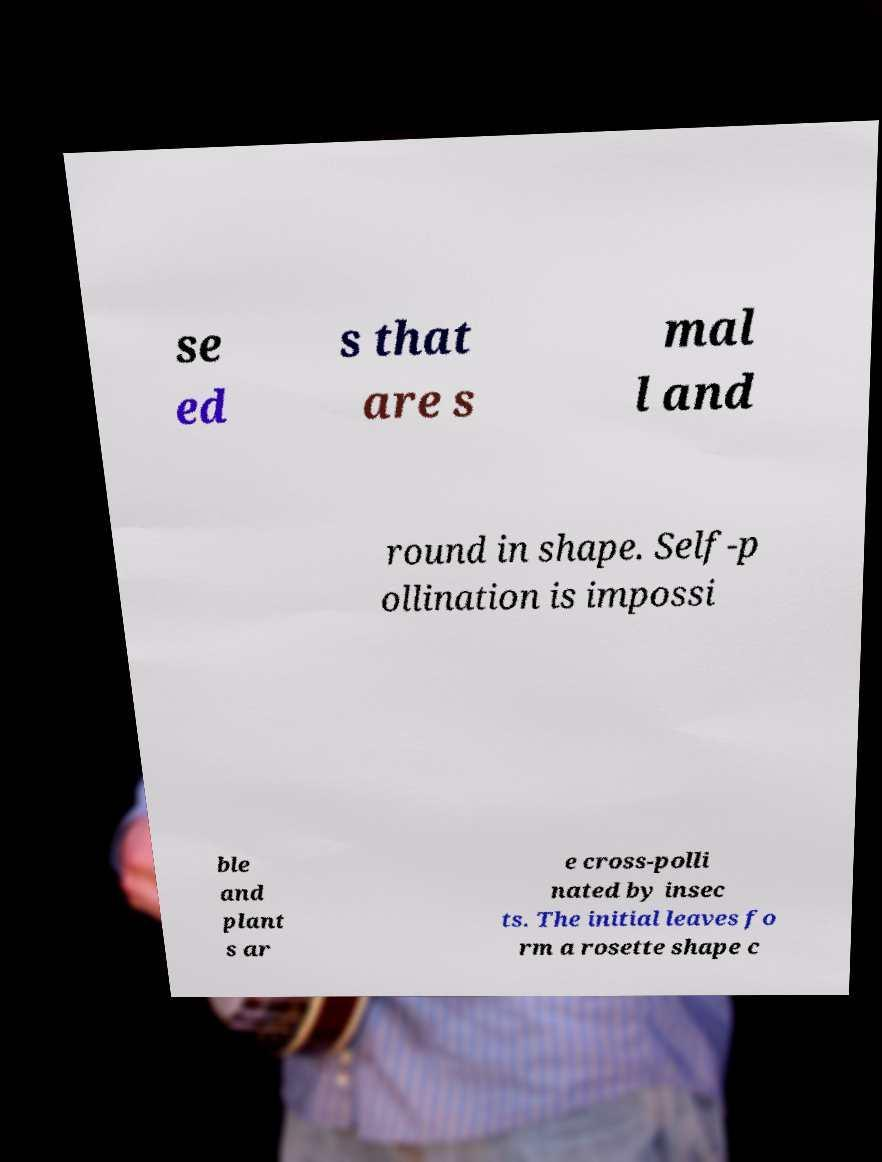What messages or text are displayed in this image? I need them in a readable, typed format. se ed s that are s mal l and round in shape. Self-p ollination is impossi ble and plant s ar e cross-polli nated by insec ts. The initial leaves fo rm a rosette shape c 